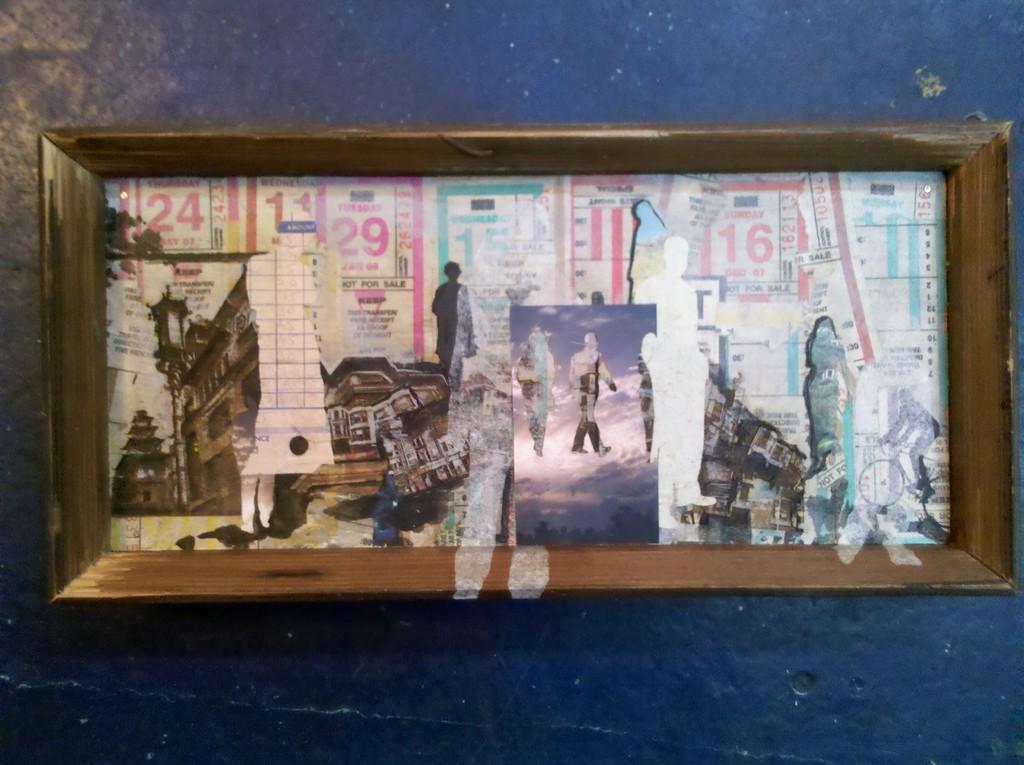Describe this image in one or two sentences. This is a wooden box and at the bottom of the box there are posters on it and it is on a platform. 